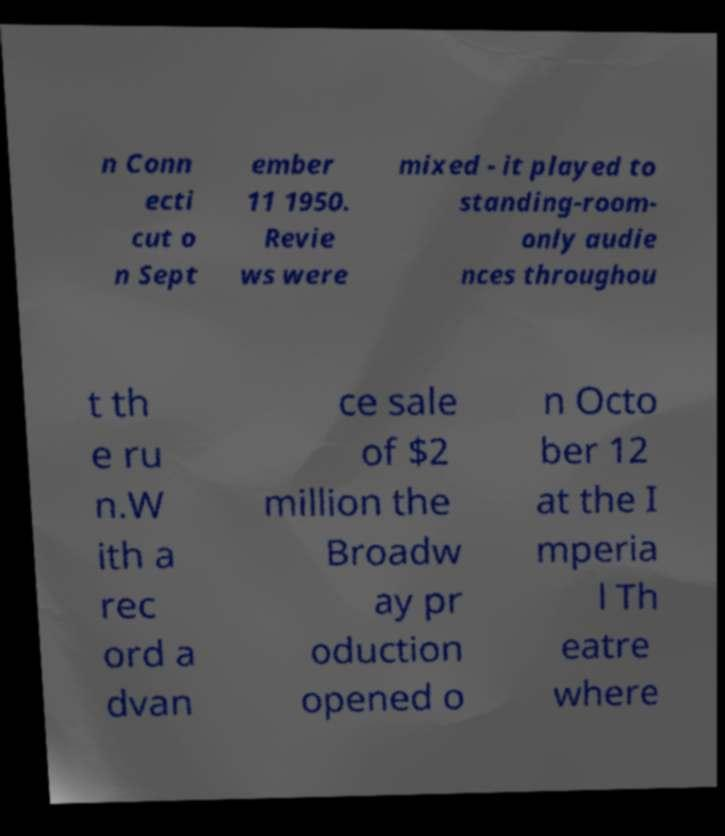There's text embedded in this image that I need extracted. Can you transcribe it verbatim? n Conn ecti cut o n Sept ember 11 1950. Revie ws were mixed - it played to standing-room- only audie nces throughou t th e ru n.W ith a rec ord a dvan ce sale of $2 million the Broadw ay pr oduction opened o n Octo ber 12 at the I mperia l Th eatre where 